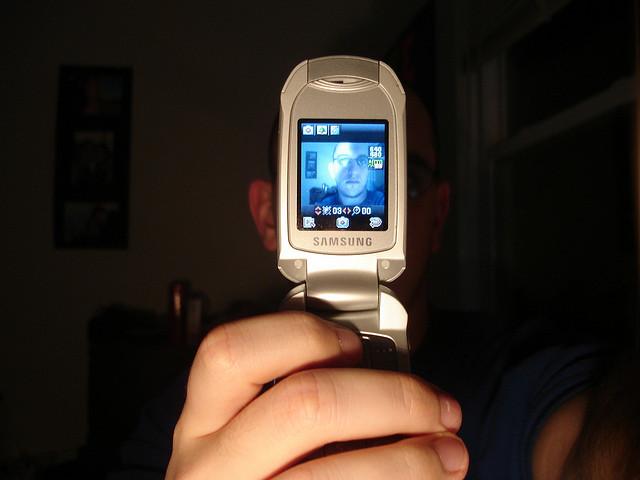Is the man taking a selfie?
Quick response, please. Yes. What type of phone is this?
Be succinct. Samsung. Does the man on the phone have  a beard?
Concise answer only. No. Is the person taking a picture?
Short answer required. Yes. What is the man doing?
Short answer required. Taking picture. 